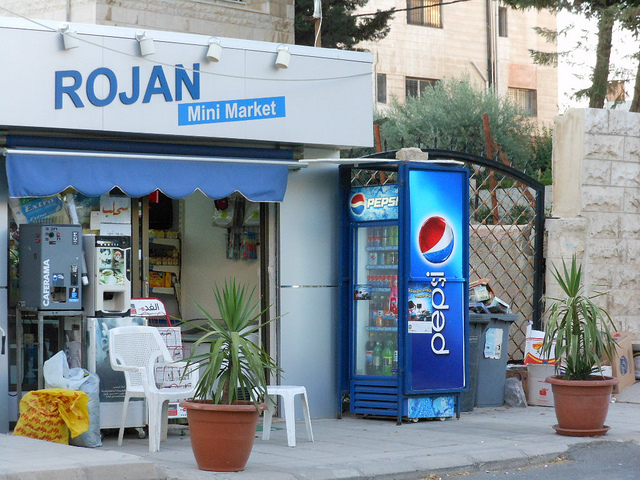What types of items can you see for sale in the store through the window? Through the window, you can see a variety of items including snacks, beverages, and other convenience goods typically found in a mini market. 